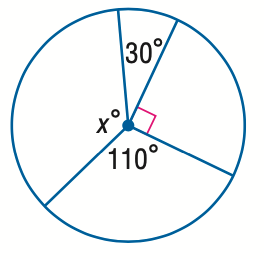Answer the mathemtical geometry problem and directly provide the correct option letter.
Question: Find the value of x.
Choices: A: 30 B: 90 C: 110 D: 130 D 